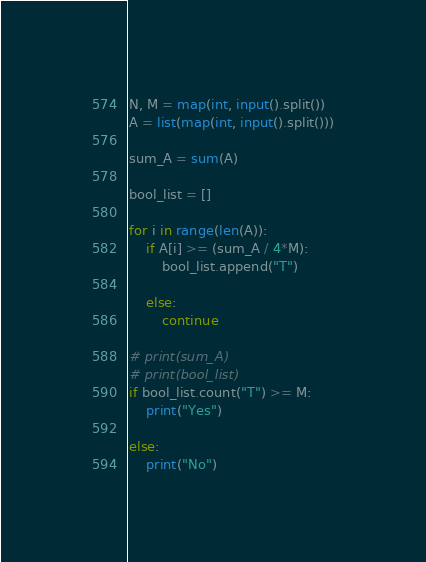Convert code to text. <code><loc_0><loc_0><loc_500><loc_500><_Python_>
N, M = map(int, input().split())
A = list(map(int, input().split()))

sum_A = sum(A)

bool_list = []

for i in range(len(A)):
    if A[i] >= (sum_A / 4*M):
        bool_list.append("T")

    else:
        continue

# print(sum_A)
# print(bool_list)
if bool_list.count("T") >= M:
    print("Yes")

else:
    print("No")

</code> 